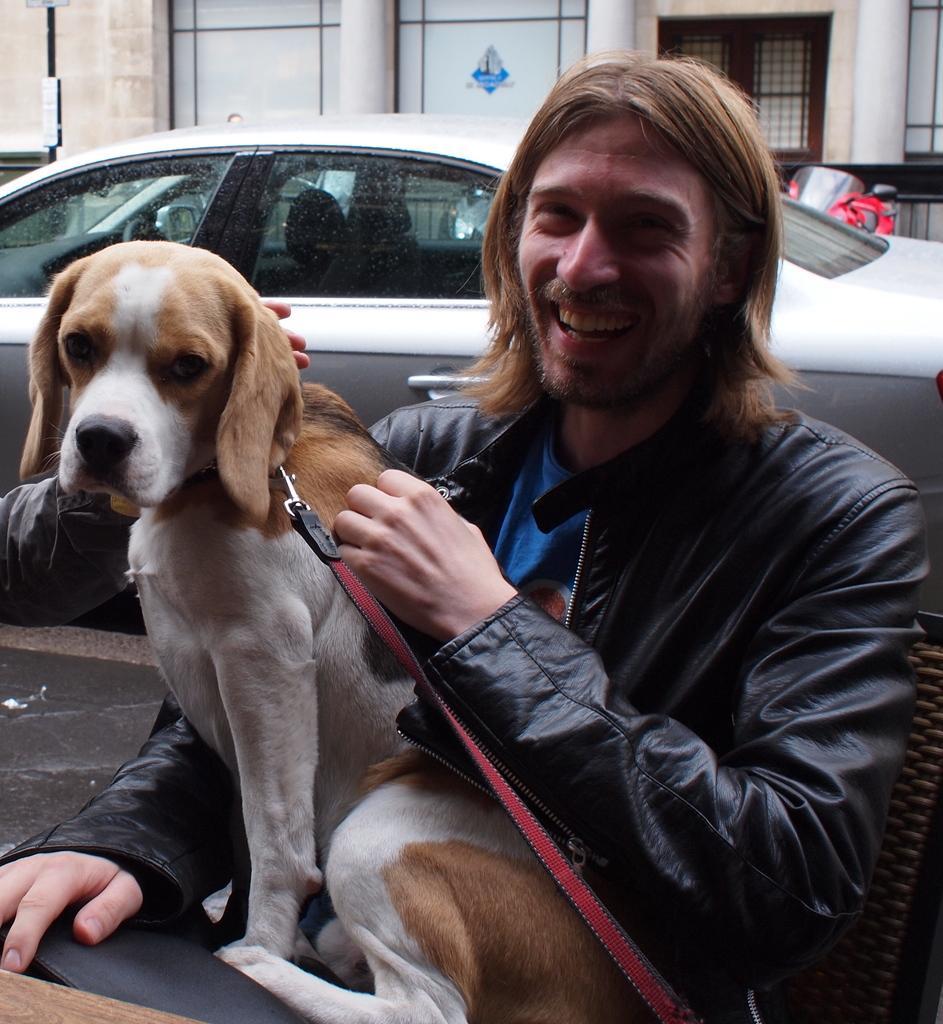Can you describe this image briefly? In this image I see a man who is smiling and he kept his hand on the dog. In the background I see the car. 